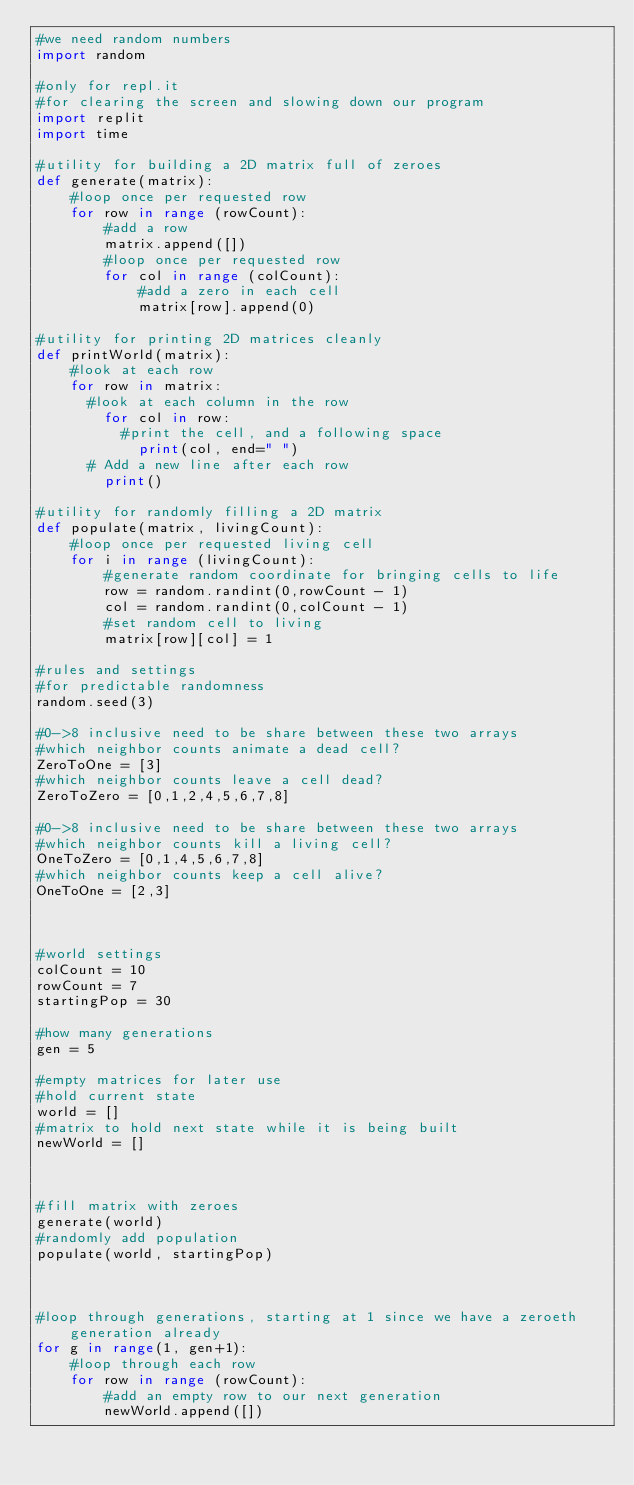Convert code to text. <code><loc_0><loc_0><loc_500><loc_500><_Python_>#we need random numbers
import random

#only for repl.it
#for clearing the screen and slowing down our program
import replit 
import time

#utility for building a 2D matrix full of zeroes
def generate(matrix):
    #loop once per requested row
    for row in range (rowCount):
        #add a row
        matrix.append([])
        #loop once per requested row
        for col in range (colCount):
            #add a zero in each cell
            matrix[row].append(0)

#utility for printing 2D matrices cleanly             
def printWorld(matrix):
    #look at each row
    for row in matrix:
	    #look at each column in the row
        for col in row:
	        #print the cell, and a following space
            print(col, end=" ")
	    # Add a new line after each row
        print()
      
#utility for randomly filling a 2D matrix   
def populate(matrix, livingCount):
    #loop once per requested living cell
    for i in range (livingCount):
        #generate random coordinate for bringing cells to life
        row = random.randint(0,rowCount - 1)
        col = random.randint(0,colCount - 1)
        #set random cell to living
        matrix[row][col] = 1

#rules and settings
#for predictable randomness
random.seed(3)

#0->8 inclusive need to be share between these two arrays
#which neighbor counts animate a dead cell?
ZeroToOne = [3]
#which neighbor counts leave a cell dead?
ZeroToZero = [0,1,2,4,5,6,7,8]

#0->8 inclusive need to be share between these two arrays
#which neighbor counts kill a living cell?
OneToZero = [0,1,4,5,6,7,8]
#which neighbor counts keep a cell alive?
OneToOne = [2,3]



#world settings
colCount = 10
rowCount = 7
startingPop = 30

#how many generations
gen = 5 

#empty matrices for later use
#hold current state
world = []
#matrix to hold next state while it is being built
newWorld = []



#fill matrix with zeroes
generate(world)
#randomly add population
populate(world, startingPop)



#loop through generations, starting at 1 since we have a zeroeth generation already
for g in range(1, gen+1):
    #loop through each row
    for row in range (rowCount):
        #add an empty row to our next generation
        newWorld.append([])</code> 